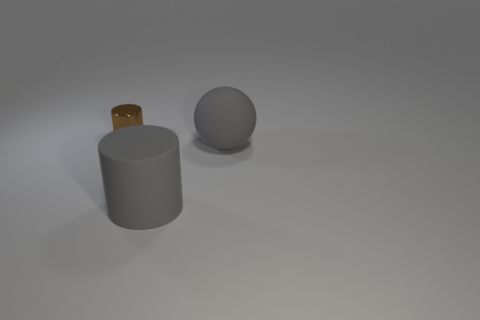Add 2 gray balls. How many objects exist? 5 Subtract all spheres. How many objects are left? 2 Add 2 small cylinders. How many small cylinders exist? 3 Subtract 0 blue spheres. How many objects are left? 3 Subtract all large gray cylinders. Subtract all gray rubber spheres. How many objects are left? 1 Add 2 rubber cylinders. How many rubber cylinders are left? 3 